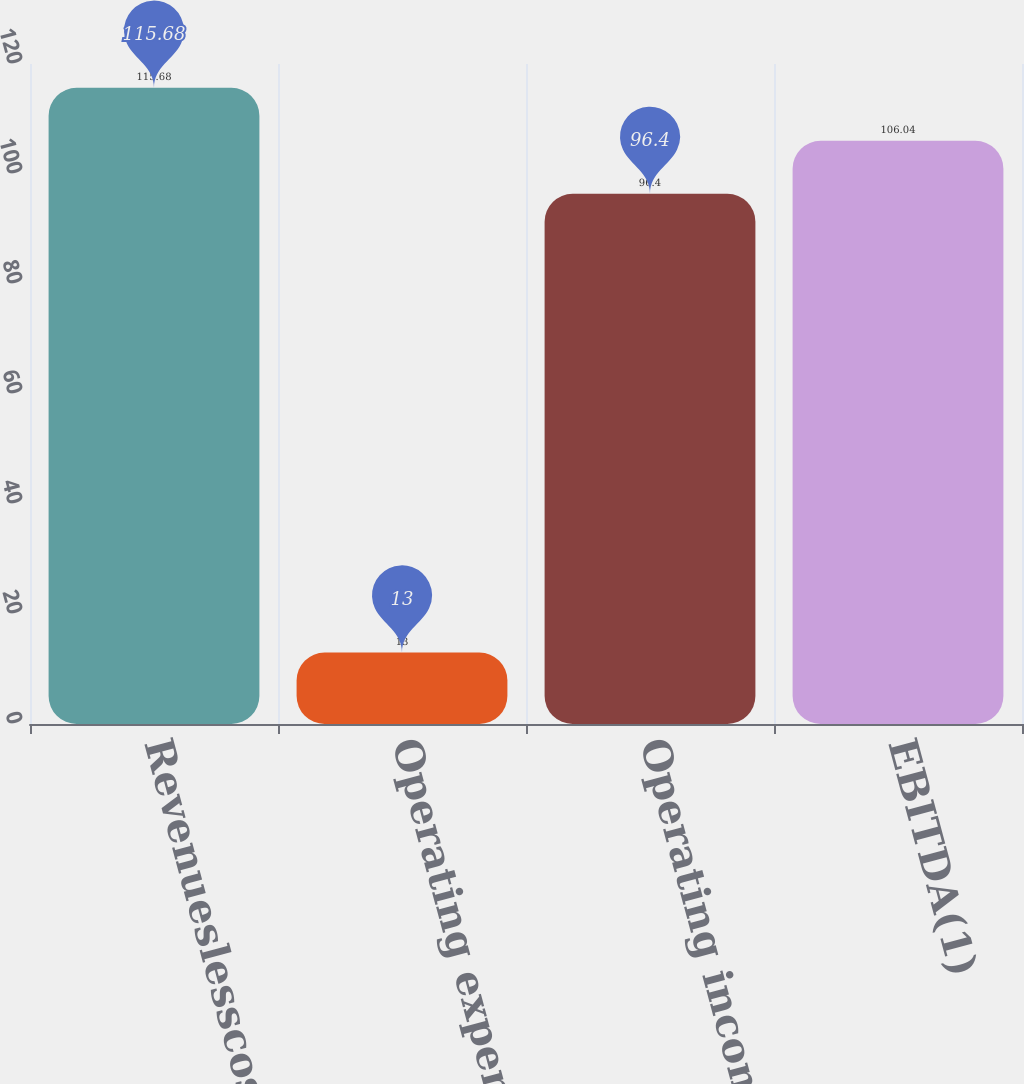Convert chart. <chart><loc_0><loc_0><loc_500><loc_500><bar_chart><fcel>Revenueslesscostofrevenues<fcel>Operating expenses<fcel>Operating income<fcel>EBITDA(1)<nl><fcel>115.68<fcel>13<fcel>96.4<fcel>106.04<nl></chart> 